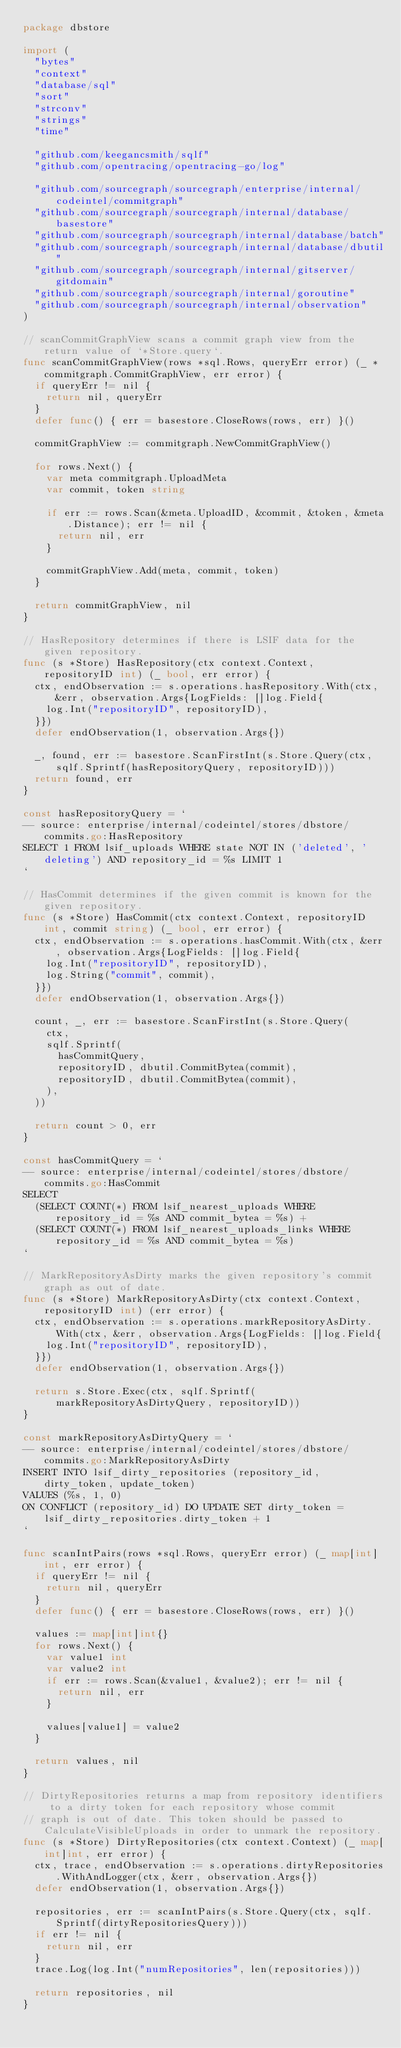<code> <loc_0><loc_0><loc_500><loc_500><_Go_>package dbstore

import (
	"bytes"
	"context"
	"database/sql"
	"sort"
	"strconv"
	"strings"
	"time"

	"github.com/keegancsmith/sqlf"
	"github.com/opentracing/opentracing-go/log"

	"github.com/sourcegraph/sourcegraph/enterprise/internal/codeintel/commitgraph"
	"github.com/sourcegraph/sourcegraph/internal/database/basestore"
	"github.com/sourcegraph/sourcegraph/internal/database/batch"
	"github.com/sourcegraph/sourcegraph/internal/database/dbutil"
	"github.com/sourcegraph/sourcegraph/internal/gitserver/gitdomain"
	"github.com/sourcegraph/sourcegraph/internal/goroutine"
	"github.com/sourcegraph/sourcegraph/internal/observation"
)

// scanCommitGraphView scans a commit graph view from the return value of `*Store.query`.
func scanCommitGraphView(rows *sql.Rows, queryErr error) (_ *commitgraph.CommitGraphView, err error) {
	if queryErr != nil {
		return nil, queryErr
	}
	defer func() { err = basestore.CloseRows(rows, err) }()

	commitGraphView := commitgraph.NewCommitGraphView()

	for rows.Next() {
		var meta commitgraph.UploadMeta
		var commit, token string

		if err := rows.Scan(&meta.UploadID, &commit, &token, &meta.Distance); err != nil {
			return nil, err
		}

		commitGraphView.Add(meta, commit, token)
	}

	return commitGraphView, nil
}

// HasRepository determines if there is LSIF data for the given repository.
func (s *Store) HasRepository(ctx context.Context, repositoryID int) (_ bool, err error) {
	ctx, endObservation := s.operations.hasRepository.With(ctx, &err, observation.Args{LogFields: []log.Field{
		log.Int("repositoryID", repositoryID),
	}})
	defer endObservation(1, observation.Args{})

	_, found, err := basestore.ScanFirstInt(s.Store.Query(ctx, sqlf.Sprintf(hasRepositoryQuery, repositoryID)))
	return found, err
}

const hasRepositoryQuery = `
-- source: enterprise/internal/codeintel/stores/dbstore/commits.go:HasRepository
SELECT 1 FROM lsif_uploads WHERE state NOT IN ('deleted', 'deleting') AND repository_id = %s LIMIT 1
`

// HasCommit determines if the given commit is known for the given repository.
func (s *Store) HasCommit(ctx context.Context, repositoryID int, commit string) (_ bool, err error) {
	ctx, endObservation := s.operations.hasCommit.With(ctx, &err, observation.Args{LogFields: []log.Field{
		log.Int("repositoryID", repositoryID),
		log.String("commit", commit),
	}})
	defer endObservation(1, observation.Args{})

	count, _, err := basestore.ScanFirstInt(s.Store.Query(
		ctx,
		sqlf.Sprintf(
			hasCommitQuery,
			repositoryID, dbutil.CommitBytea(commit),
			repositoryID, dbutil.CommitBytea(commit),
		),
	))

	return count > 0, err
}

const hasCommitQuery = `
-- source: enterprise/internal/codeintel/stores/dbstore/commits.go:HasCommit
SELECT
	(SELECT COUNT(*) FROM lsif_nearest_uploads WHERE repository_id = %s AND commit_bytea = %s) +
	(SELECT COUNT(*) FROM lsif_nearest_uploads_links WHERE repository_id = %s AND commit_bytea = %s)
`

// MarkRepositoryAsDirty marks the given repository's commit graph as out of date.
func (s *Store) MarkRepositoryAsDirty(ctx context.Context, repositoryID int) (err error) {
	ctx, endObservation := s.operations.markRepositoryAsDirty.With(ctx, &err, observation.Args{LogFields: []log.Field{
		log.Int("repositoryID", repositoryID),
	}})
	defer endObservation(1, observation.Args{})

	return s.Store.Exec(ctx, sqlf.Sprintf(markRepositoryAsDirtyQuery, repositoryID))
}

const markRepositoryAsDirtyQuery = `
-- source: enterprise/internal/codeintel/stores/dbstore/commits.go:MarkRepositoryAsDirty
INSERT INTO lsif_dirty_repositories (repository_id, dirty_token, update_token)
VALUES (%s, 1, 0)
ON CONFLICT (repository_id) DO UPDATE SET dirty_token = lsif_dirty_repositories.dirty_token + 1
`

func scanIntPairs(rows *sql.Rows, queryErr error) (_ map[int]int, err error) {
	if queryErr != nil {
		return nil, queryErr
	}
	defer func() { err = basestore.CloseRows(rows, err) }()

	values := map[int]int{}
	for rows.Next() {
		var value1 int
		var value2 int
		if err := rows.Scan(&value1, &value2); err != nil {
			return nil, err
		}

		values[value1] = value2
	}

	return values, nil
}

// DirtyRepositories returns a map from repository identifiers to a dirty token for each repository whose commit
// graph is out of date. This token should be passed to CalculateVisibleUploads in order to unmark the repository.
func (s *Store) DirtyRepositories(ctx context.Context) (_ map[int]int, err error) {
	ctx, trace, endObservation := s.operations.dirtyRepositories.WithAndLogger(ctx, &err, observation.Args{})
	defer endObservation(1, observation.Args{})

	repositories, err := scanIntPairs(s.Store.Query(ctx, sqlf.Sprintf(dirtyRepositoriesQuery)))
	if err != nil {
		return nil, err
	}
	trace.Log(log.Int("numRepositories", len(repositories)))

	return repositories, nil
}
</code> 